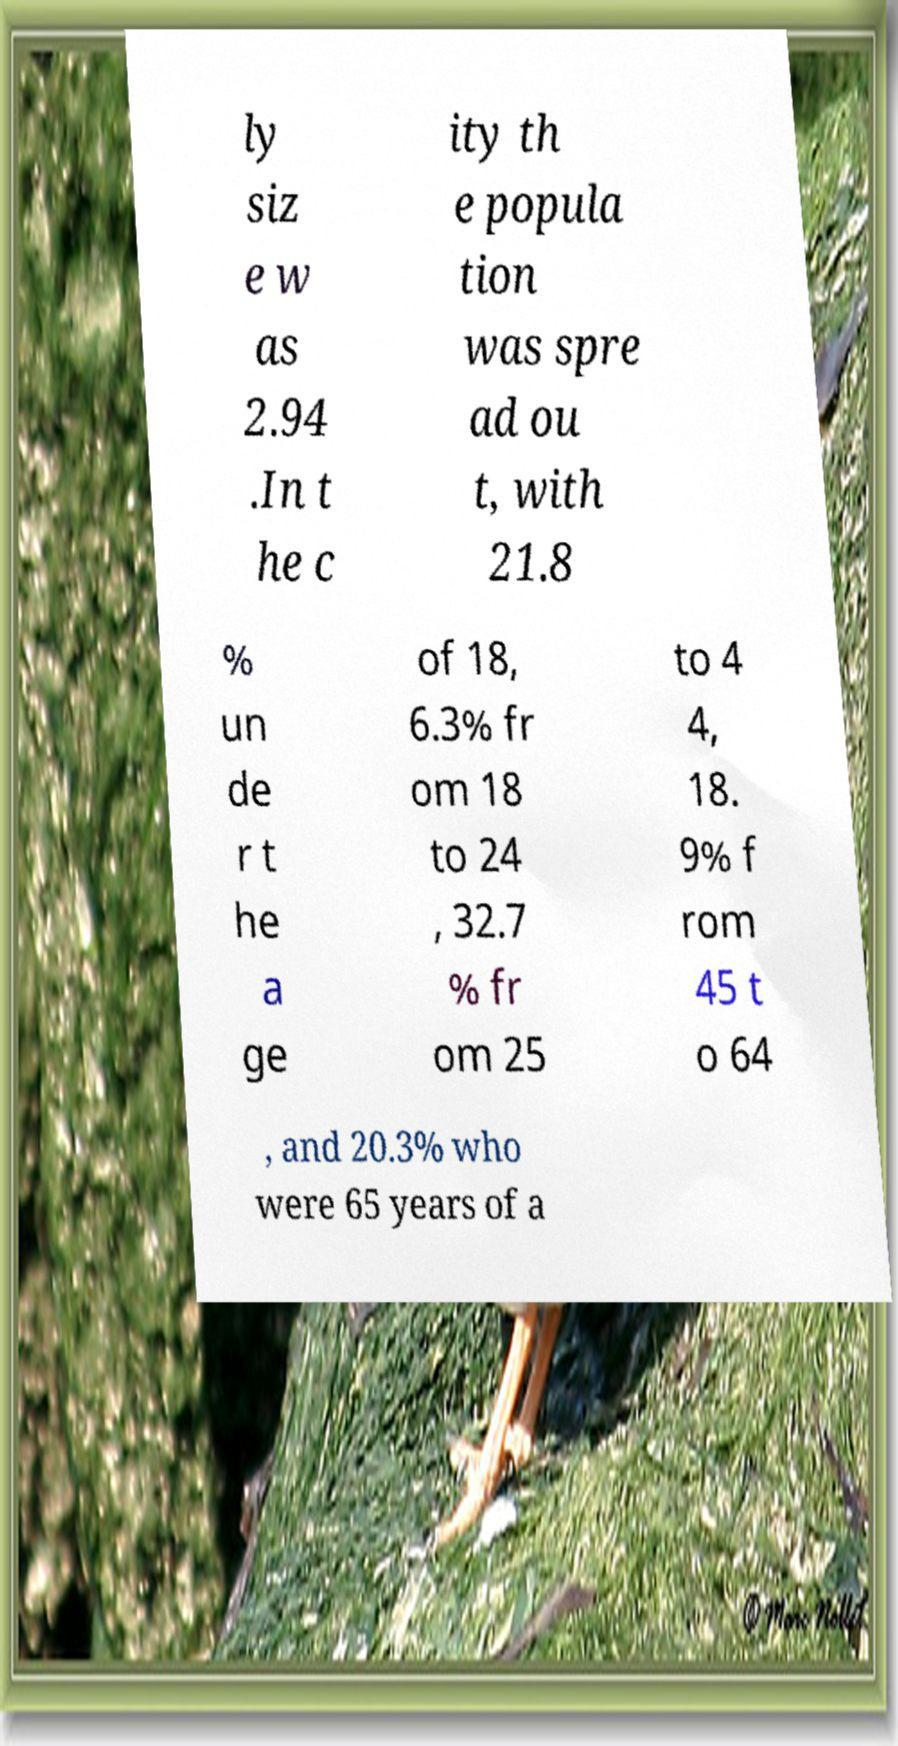Can you read and provide the text displayed in the image?This photo seems to have some interesting text. Can you extract and type it out for me? ly siz e w as 2.94 .In t he c ity th e popula tion was spre ad ou t, with 21.8 % un de r t he a ge of 18, 6.3% fr om 18 to 24 , 32.7 % fr om 25 to 4 4, 18. 9% f rom 45 t o 64 , and 20.3% who were 65 years of a 